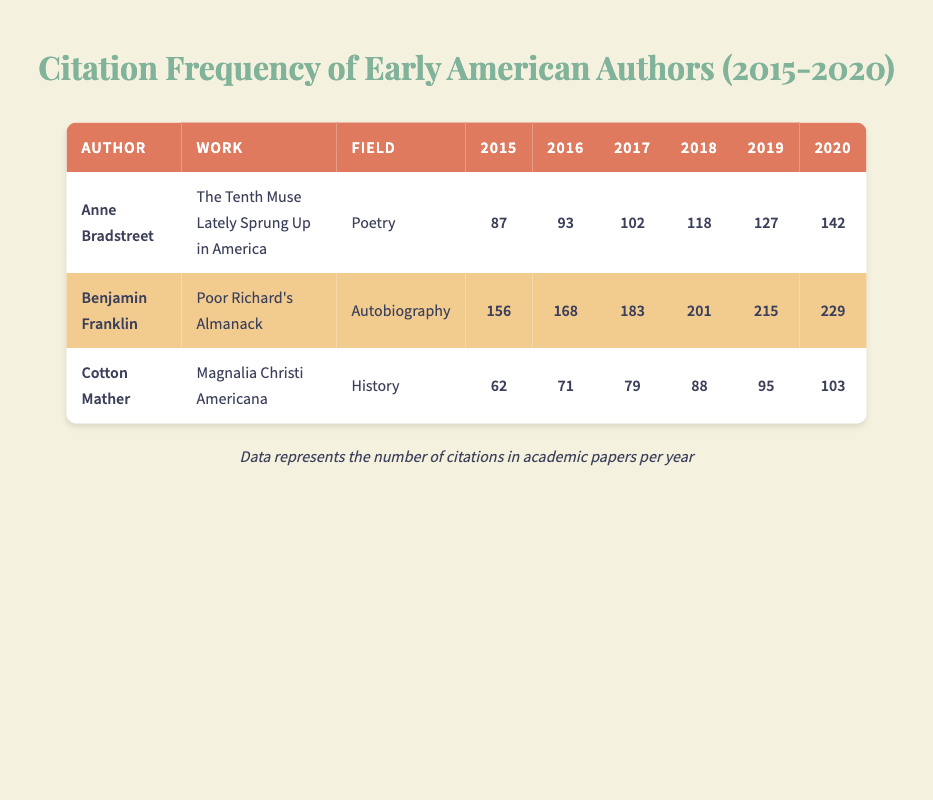What was the total number of citations for Benjamin Franklin's work from 2015 to 2020? To find the total citations for Benjamin Franklin from 2015 to 2020, I need to add the citations for each year: 156 (2015) + 168 (2016) + 183 (2017) + 201 (2018) + 215 (2019) + 229 (2020) = 1152.
Answer: 1152 Which author had the highest number of citations in 2018? In 2018, Anne Bradstreet had 118 citations, Benjamin Franklin had 201 citations, and Cotton Mather had 88 citations. The largest number of citations is from Benjamin Franklin with 201.
Answer: 201 Did Cotton Mather's citations increase or decrease from 2016 to 2020? Cotton Mather had 71 citations in 2016 and 103 citations in 2020. Since 103 is greater than 71, his citations increased over this period.
Answer: Yes What was the average number of citations per year for Anne Bradstreet from 2015 to 2020? To calculate the average, I need to sum her citations (87 + 93 + 102 + 118 + 127 + 142 = 769) and divide by the number of years (6). The average is 769/6 = 128.17.
Answer: 128.17 In which year did Cotton Mather receive the least citations? From the data, Cotton Mather's citations were 62 in 2015, 71 in 2016, 79 in 2017, 88 in 2018, 95 in 2019, and 103 in 2020. The least citations were in 2015 with 62.
Answer: 2015 What is the sum of citations for all authors in 2017? For 2017, the citations are: Anne Bradstreet 102, Benjamin Franklin 183, and Cotton Mather 79. The total is 102 + 183 + 79 = 364.
Answer: 364 Did Anne Bradstreet ever receive more citations than Cotton Mather in the same year? Checking the citations year-by-year: In 2015, Anne Bradstreet (87) had more than Cotton Mather (62); in 2016, she had 93 versus 71; in 2017, she had 102 versus 79; in 2018, she had 118 compared to 88; in 2019, she had 127 compared to 95; in 2020, she had 142 compared to 103. Yes, she did in every year.
Answer: Yes Which author showed the greatest increase in citations from their lowest year to their highest year? Tracking the citations: Anne Bradstreet increased from 87 (2015) to 142 (2020) for an increase of 55. Benjamin Franklin increased from 156 (2015) to 229 (2020) for an increase of 73. Cotton Mather increased from 62 (2015) to 103 (2020) for an increase of 41. The greatest increase is by Benjamin Franklin at 73.
Answer: Benjamin Franklin 